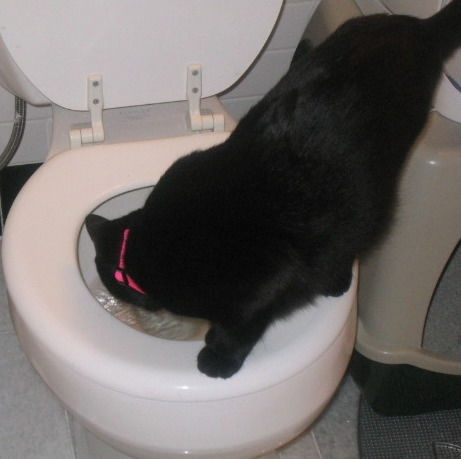Describe the objects in this image and their specific colors. I can see toilet in gray, darkgray, and lightgray tones and cat in lightgray, black, gray, and maroon tones in this image. 